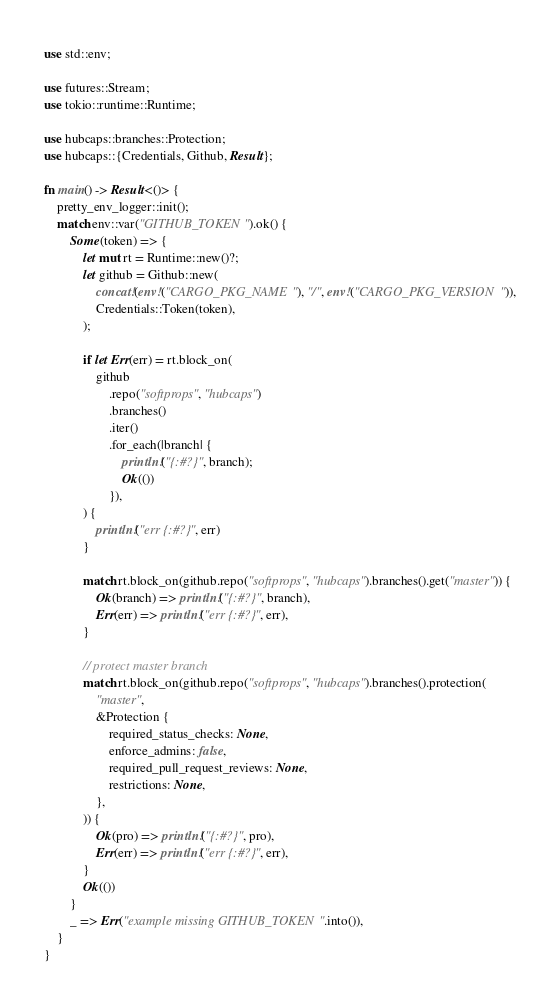Convert code to text. <code><loc_0><loc_0><loc_500><loc_500><_Rust_>use std::env;

use futures::Stream;
use tokio::runtime::Runtime;

use hubcaps::branches::Protection;
use hubcaps::{Credentials, Github, Result};

fn main() -> Result<()> {
    pretty_env_logger::init();
    match env::var("GITHUB_TOKEN").ok() {
        Some(token) => {
            let mut rt = Runtime::new()?;
            let github = Github::new(
                concat!(env!("CARGO_PKG_NAME"), "/", env!("CARGO_PKG_VERSION")),
                Credentials::Token(token),
            );

            if let Err(err) = rt.block_on(
                github
                    .repo("softprops", "hubcaps")
                    .branches()
                    .iter()
                    .for_each(|branch| {
                        println!("{:#?}", branch);
                        Ok(())
                    }),
            ) {
                println!("err {:#?}", err)
            }

            match rt.block_on(github.repo("softprops", "hubcaps").branches().get("master")) {
                Ok(branch) => println!("{:#?}", branch),
                Err(err) => println!("err {:#?}", err),
            }

            // protect master branch
            match rt.block_on(github.repo("softprops", "hubcaps").branches().protection(
                "master",
                &Protection {
                    required_status_checks: None,
                    enforce_admins: false,
                    required_pull_request_reviews: None,
                    restrictions: None,
                },
            )) {
                Ok(pro) => println!("{:#?}", pro),
                Err(err) => println!("err {:#?}", err),
            }
            Ok(())
        }
        _ => Err("example missing GITHUB_TOKEN".into()),
    }
}
</code> 